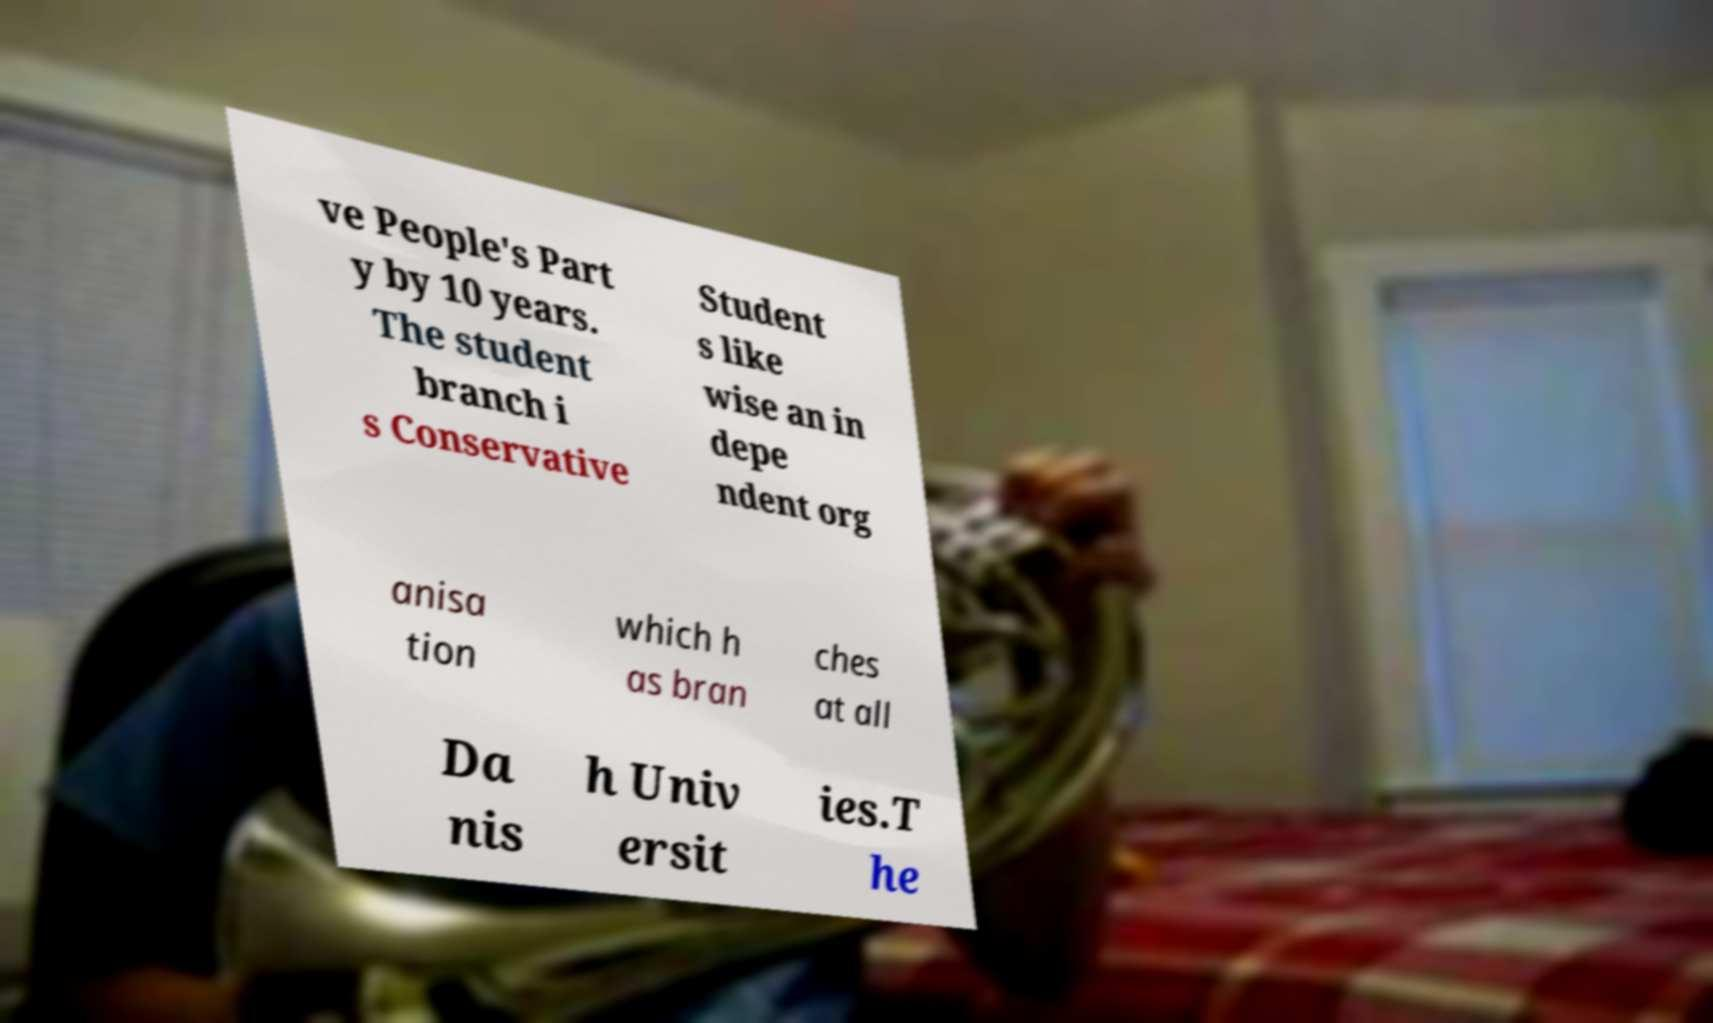What messages or text are displayed in this image? I need them in a readable, typed format. ve People's Part y by 10 years. The student branch i s Conservative Student s like wise an in depe ndent org anisa tion which h as bran ches at all Da nis h Univ ersit ies.T he 